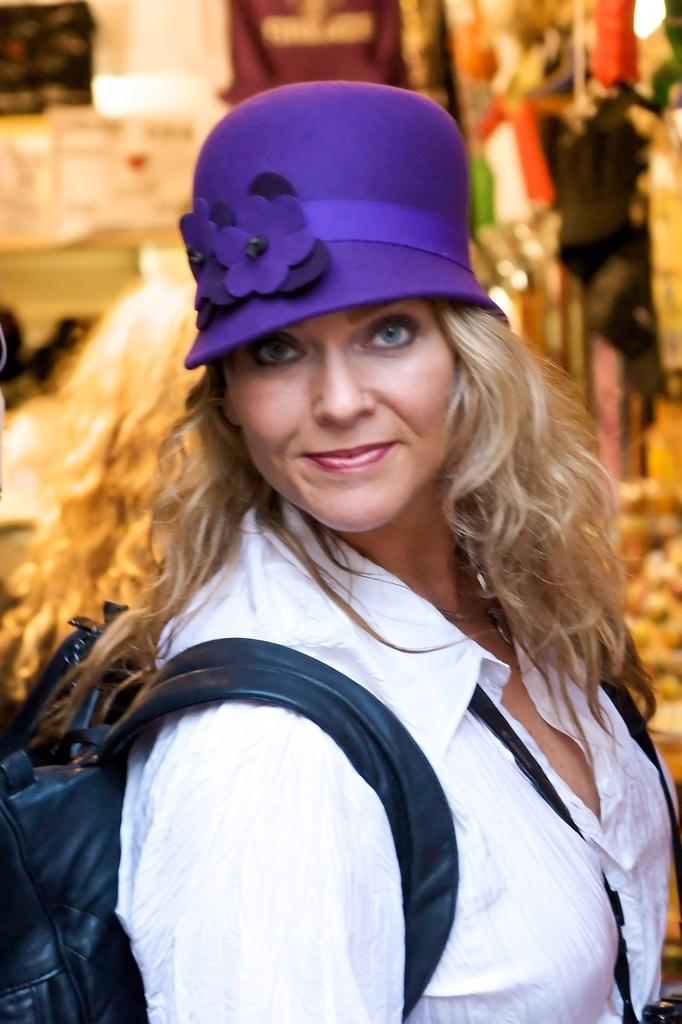Who is the main subject in the image? There is a woman in the image. What is the woman carrying? The woman is carrying a bag. What is the woman wearing on her shoulders and neck? The woman has an object on her shoulders and neck. What type of headwear is the woman wearing? The woman is wearing a cap. How would you describe the background of the image? The background of the image is blurred. What else can be seen in the background besides the blurred area? Clothes and other objects are visible in the background. What type of board is the woman riding in the image? There is no board present in the image; the woman is not riding anything. How many bananas can be seen in the woman's hand in the image? There are no bananas visible in the woman's hand or anywhere else in the image. 